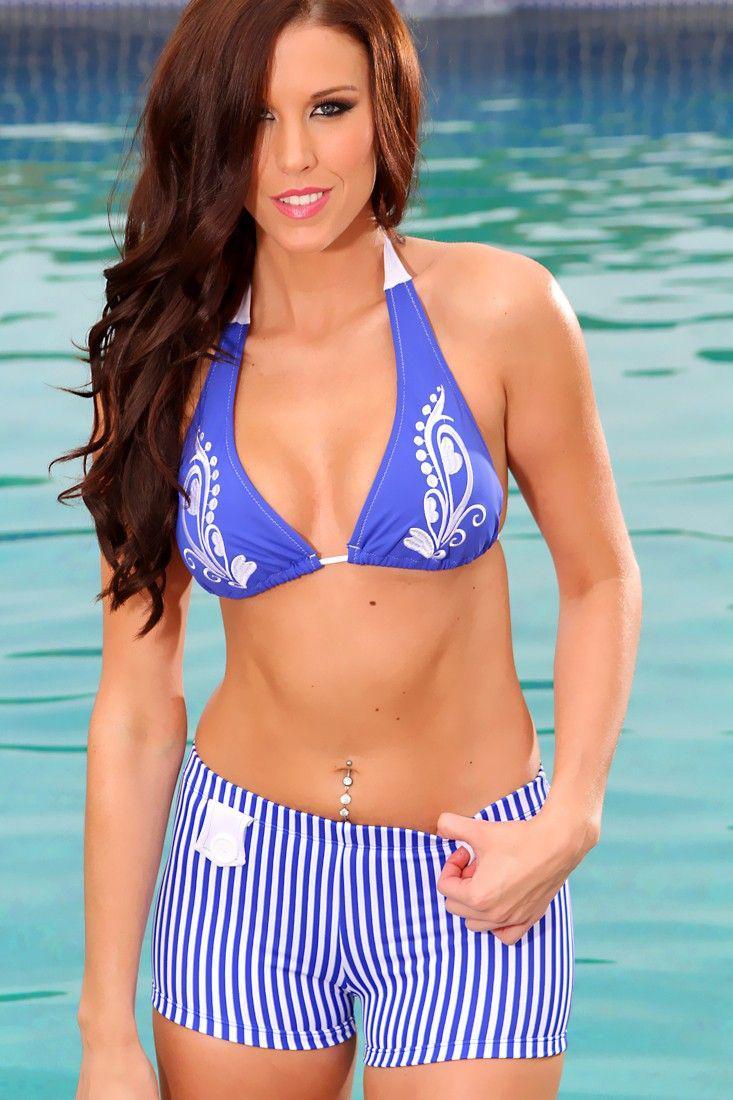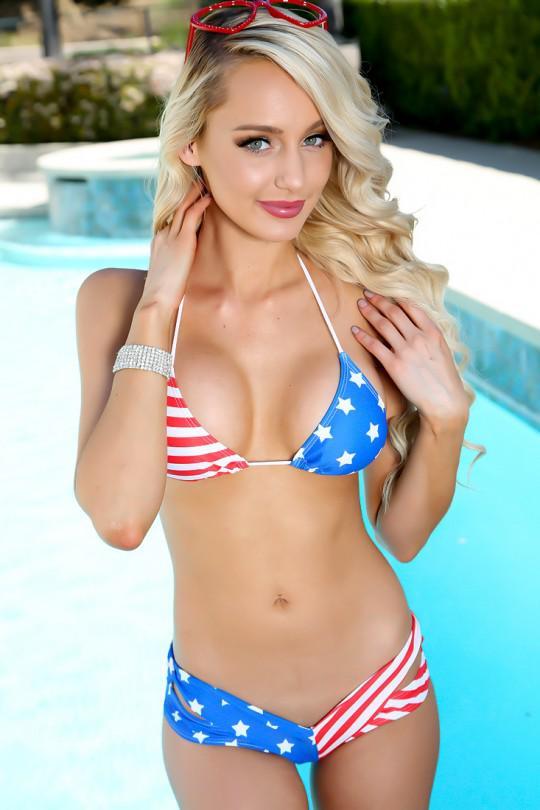The first image is the image on the left, the second image is the image on the right. For the images shown, is this caption "At least one woman has sunglasses on her head." true? Answer yes or no. Yes. 